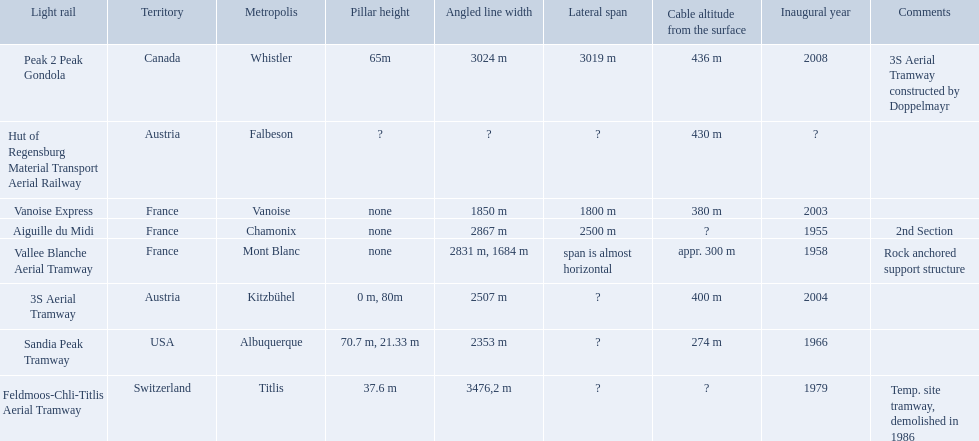Which tramways are in france? Vanoise Express, Aiguille du Midi, Vallee Blanche Aerial Tramway. Which of those were inaugurated in the 1950? Aiguille du Midi, Vallee Blanche Aerial Tramway. Which of these tramways span is not almost horizontal? Aiguille du Midi. 